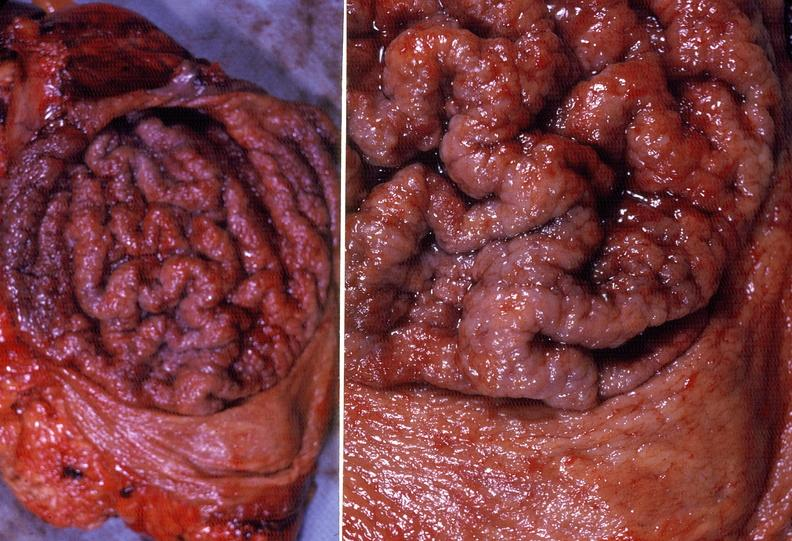what is present?
Answer the question using a single word or phrase. Gastrointestinal 